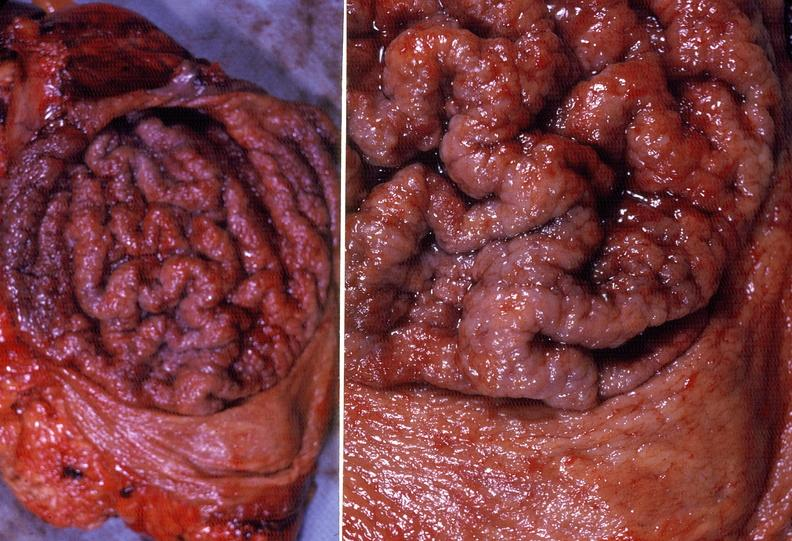what is present?
Answer the question using a single word or phrase. Gastrointestinal 